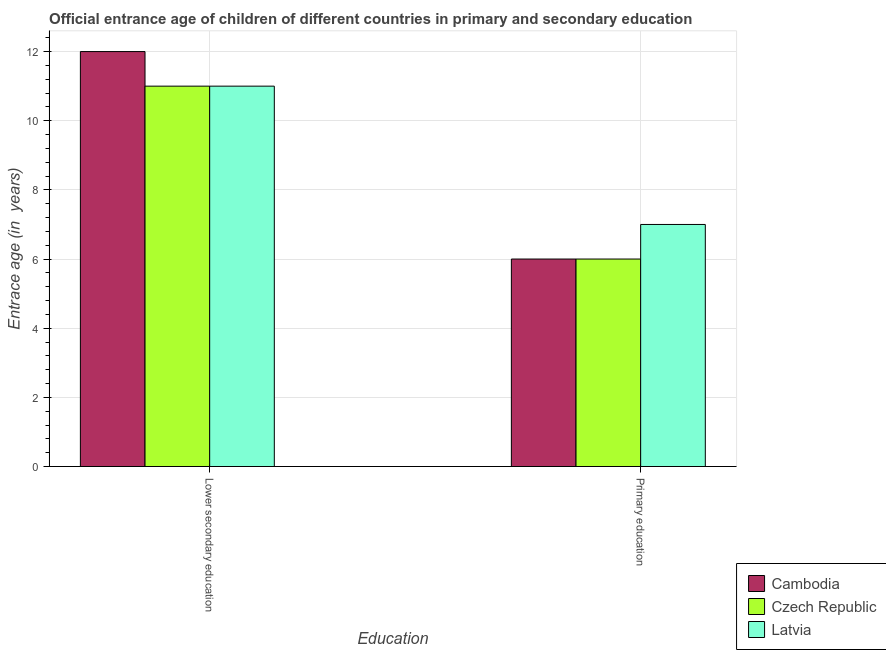Are the number of bars on each tick of the X-axis equal?
Provide a short and direct response. Yes. What is the label of the 1st group of bars from the left?
Keep it short and to the point. Lower secondary education. Across all countries, what is the maximum entrance age of chiildren in primary education?
Give a very brief answer. 7. Across all countries, what is the minimum entrance age of chiildren in primary education?
Provide a short and direct response. 6. In which country was the entrance age of children in lower secondary education maximum?
Provide a succinct answer. Cambodia. In which country was the entrance age of children in lower secondary education minimum?
Provide a succinct answer. Czech Republic. What is the total entrance age of children in lower secondary education in the graph?
Your answer should be compact. 34. What is the difference between the entrance age of children in lower secondary education in Latvia and the entrance age of chiildren in primary education in Czech Republic?
Your answer should be very brief. 5. What is the average entrance age of chiildren in primary education per country?
Keep it short and to the point. 6.33. What is the difference between the entrance age of chiildren in primary education and entrance age of children in lower secondary education in Latvia?
Your answer should be compact. -4. In how many countries, is the entrance age of children in lower secondary education greater than 5.6 years?
Your response must be concise. 3. In how many countries, is the entrance age of children in lower secondary education greater than the average entrance age of children in lower secondary education taken over all countries?
Your answer should be very brief. 1. What does the 3rd bar from the left in Primary education represents?
Provide a succinct answer. Latvia. What does the 1st bar from the right in Lower secondary education represents?
Offer a terse response. Latvia. How many bars are there?
Ensure brevity in your answer.  6. Are all the bars in the graph horizontal?
Offer a very short reply. No. How many countries are there in the graph?
Provide a short and direct response. 3. What is the difference between two consecutive major ticks on the Y-axis?
Offer a very short reply. 2. Are the values on the major ticks of Y-axis written in scientific E-notation?
Offer a very short reply. No. Does the graph contain grids?
Your response must be concise. Yes. How are the legend labels stacked?
Offer a terse response. Vertical. What is the title of the graph?
Provide a succinct answer. Official entrance age of children of different countries in primary and secondary education. What is the label or title of the X-axis?
Make the answer very short. Education. What is the label or title of the Y-axis?
Keep it short and to the point. Entrace age (in  years). What is the Entrace age (in  years) in Latvia in Lower secondary education?
Ensure brevity in your answer.  11. What is the Entrace age (in  years) in Latvia in Primary education?
Ensure brevity in your answer.  7. Across all Education, what is the maximum Entrace age (in  years) of Czech Republic?
Keep it short and to the point. 11. Across all Education, what is the minimum Entrace age (in  years) in Cambodia?
Your answer should be very brief. 6. Across all Education, what is the minimum Entrace age (in  years) of Latvia?
Offer a very short reply. 7. What is the total Entrace age (in  years) of Cambodia in the graph?
Provide a short and direct response. 18. What is the total Entrace age (in  years) in Latvia in the graph?
Your answer should be compact. 18. What is the difference between the Entrace age (in  years) in Cambodia in Lower secondary education and that in Primary education?
Ensure brevity in your answer.  6. What is the difference between the Entrace age (in  years) in Latvia in Lower secondary education and that in Primary education?
Keep it short and to the point. 4. What is the difference between the Entrace age (in  years) in Cambodia in Lower secondary education and the Entrace age (in  years) in Czech Republic in Primary education?
Your answer should be very brief. 6. What is the average Entrace age (in  years) of Cambodia per Education?
Offer a very short reply. 9. What is the difference between the Entrace age (in  years) of Cambodia and Entrace age (in  years) of Latvia in Lower secondary education?
Ensure brevity in your answer.  1. What is the difference between the Entrace age (in  years) in Cambodia and Entrace age (in  years) in Latvia in Primary education?
Your answer should be compact. -1. What is the difference between the Entrace age (in  years) of Czech Republic and Entrace age (in  years) of Latvia in Primary education?
Provide a succinct answer. -1. What is the ratio of the Entrace age (in  years) in Cambodia in Lower secondary education to that in Primary education?
Your response must be concise. 2. What is the ratio of the Entrace age (in  years) of Czech Republic in Lower secondary education to that in Primary education?
Keep it short and to the point. 1.83. What is the ratio of the Entrace age (in  years) in Latvia in Lower secondary education to that in Primary education?
Give a very brief answer. 1.57. What is the difference between the highest and the second highest Entrace age (in  years) of Czech Republic?
Your answer should be compact. 5. What is the difference between the highest and the second highest Entrace age (in  years) of Latvia?
Keep it short and to the point. 4. What is the difference between the highest and the lowest Entrace age (in  years) of Cambodia?
Your response must be concise. 6. What is the difference between the highest and the lowest Entrace age (in  years) in Latvia?
Ensure brevity in your answer.  4. 